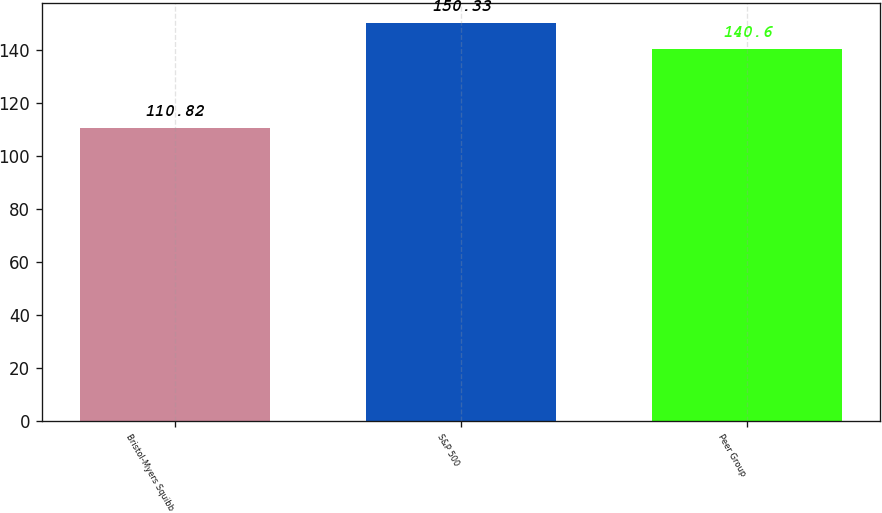<chart> <loc_0><loc_0><loc_500><loc_500><bar_chart><fcel>Bristol-Myers Squibb<fcel>S&P 500<fcel>Peer Group<nl><fcel>110.82<fcel>150.33<fcel>140.6<nl></chart> 